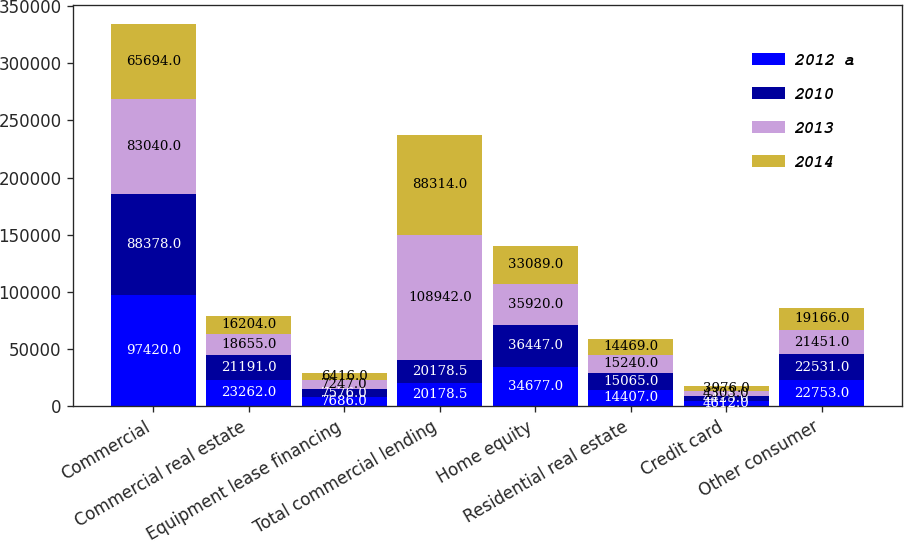<chart> <loc_0><loc_0><loc_500><loc_500><stacked_bar_chart><ecel><fcel>Commercial<fcel>Commercial real estate<fcel>Equipment lease financing<fcel>Total commercial lending<fcel>Home equity<fcel>Residential real estate<fcel>Credit card<fcel>Other consumer<nl><fcel>2012 a<fcel>97420<fcel>23262<fcel>7686<fcel>20178.5<fcel>34677<fcel>14407<fcel>4612<fcel>22753<nl><fcel>2010<fcel>88378<fcel>21191<fcel>7576<fcel>20178.5<fcel>36447<fcel>15065<fcel>4425<fcel>22531<nl><fcel>2013<fcel>83040<fcel>18655<fcel>7247<fcel>108942<fcel>35920<fcel>15240<fcel>4303<fcel>21451<nl><fcel>2014<fcel>65694<fcel>16204<fcel>6416<fcel>88314<fcel>33089<fcel>14469<fcel>3976<fcel>19166<nl></chart> 